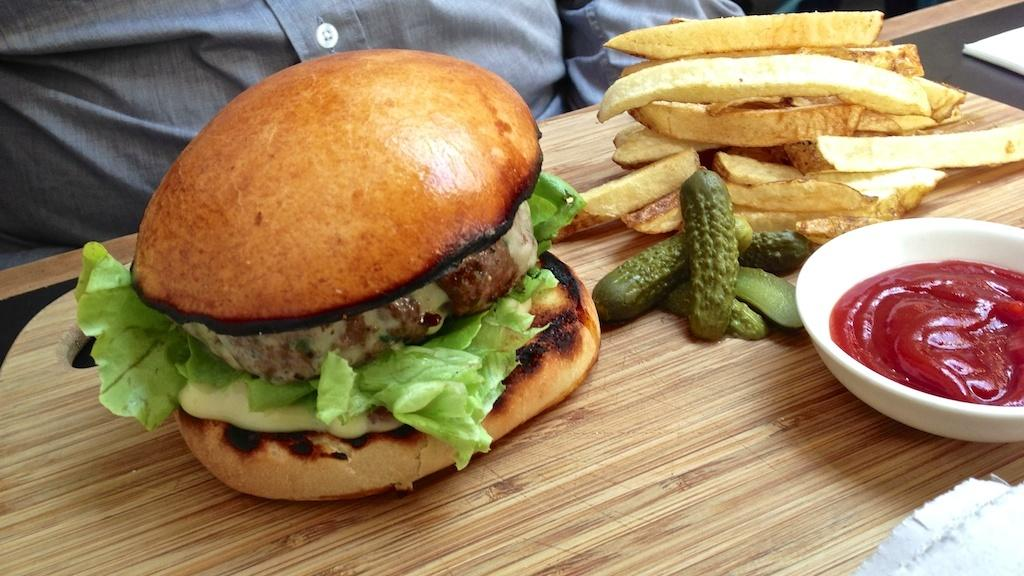What type of food is the main subject of the image? There is a hand burger in the image. What other food items can be seen in the image? There are french fries and ketchup in a cup in the image. What is used for cleaning or wiping in the image? There is a napkin in the image. How are the food items arranged in the image? The items are on a wooden tray in the image. Is there a person present in the image? Yes, there is a person in the image. What type of horse can be seen in the image? There is no horse present in the image. Can you tell me how many tigers are visible in the image? There are no tigers present in the image. 